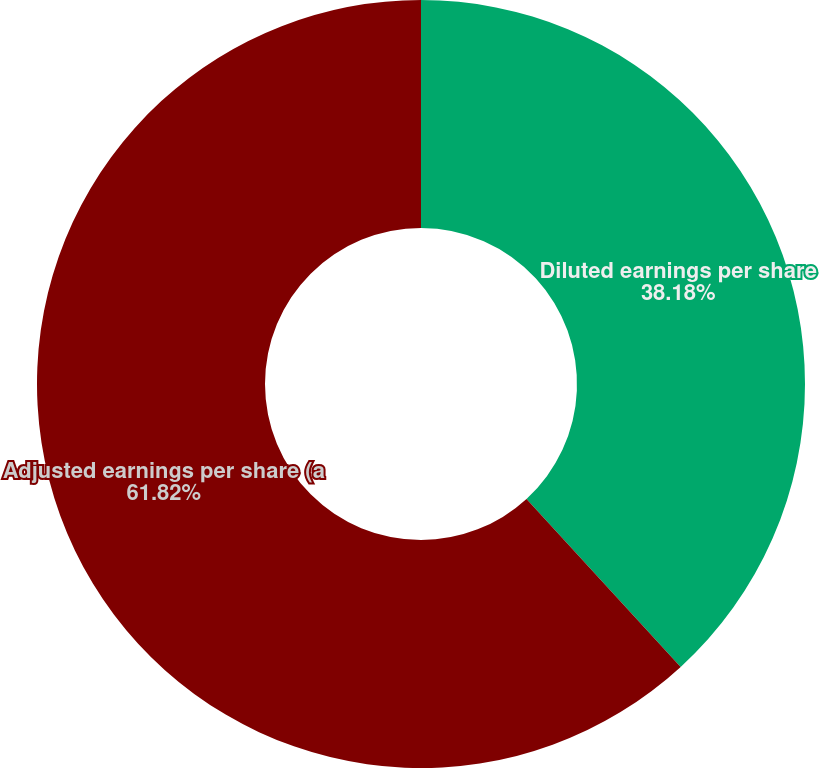Convert chart to OTSL. <chart><loc_0><loc_0><loc_500><loc_500><pie_chart><fcel>Diluted earnings per share<fcel>Adjusted earnings per share (a<nl><fcel>38.18%<fcel>61.82%<nl></chart> 